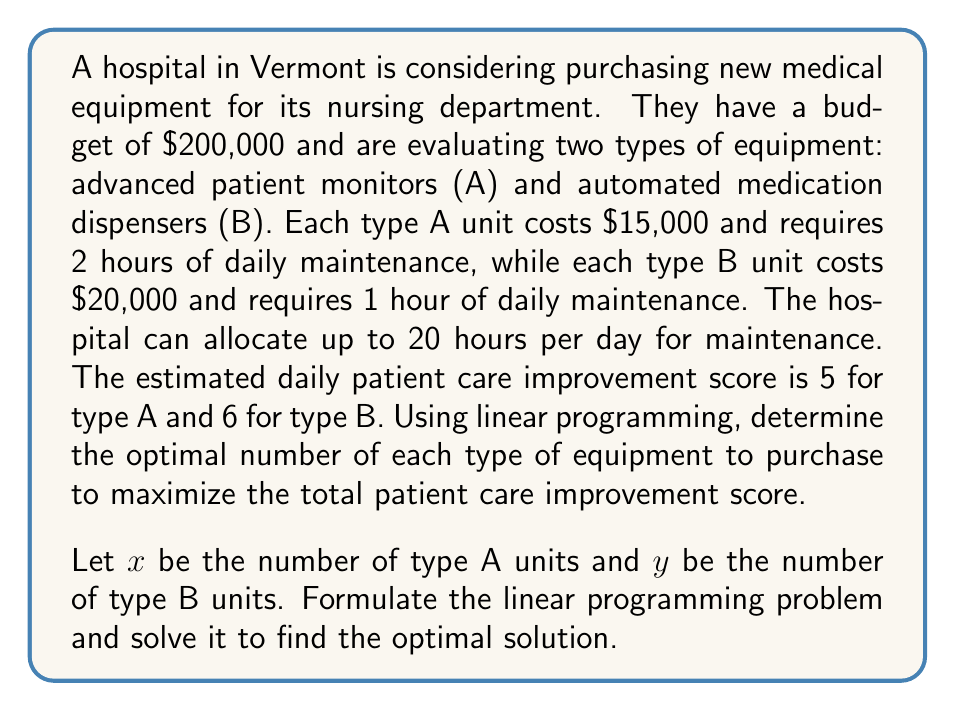Can you solve this math problem? To solve this linear programming problem, we'll follow these steps:

1. Define the objective function:
   Maximize $Z = 5x + 6y$ (total patient care improvement score)

2. Identify the constraints:
   a) Budget constraint: $15000x + 20000y \leq 200000$
   b) Maintenance time constraint: $2x + y \leq 20$
   c) Non-negativity constraints: $x \geq 0, y \geq 0$

3. Simplify the constraints:
   a) $3x + 4y \leq 40$
   b) $2x + y \leq 20$

4. Graph the feasible region:
   [asy]
   import geometry;
   
   size(200);
   
   real xmax = 15;
   real ymax = 15;
   
   draw((0,0)--(xmax,0)--(xmax,ymax)--(0,ymax)--cycle);
   
   draw((0,10)--(40/3,0), blue);
   draw((0,20)--(10,0), red);
   
   label("$3x + 4y = 40$", (13,3), E, blue);
   label("$2x + y = 20$", (11,9), E, red);
   
   dot((0,10), green);
   dot((40/3,0), green);
   dot((10,0), green);
   dot((8,4), green);
   
   label("(0,10)", (0,10), W);
   label("(40/3,0)", (40/3,0), S);
   label("(10,0)", (10,0), S);
   label("(8,4)", (8,4), NE);
   [/asy]

5. Identify the corner points of the feasible region:
   (0,0), (0,10), (8,4), (10,0)

6. Evaluate the objective function at each corner point:
   $Z(0,0) = 0$
   $Z(0,10) = 60$
   $Z(8,4) = 64$
   $Z(10,0) = 50$

7. The maximum value occurs at the point (8,4), which gives the optimal solution.

Therefore, the hospital should purchase 8 units of type A equipment (advanced patient monitors) and 4 units of type B equipment (automated medication dispensers) to maximize the total patient care improvement score of 64.
Answer: 8 type A units, 4 type B units 